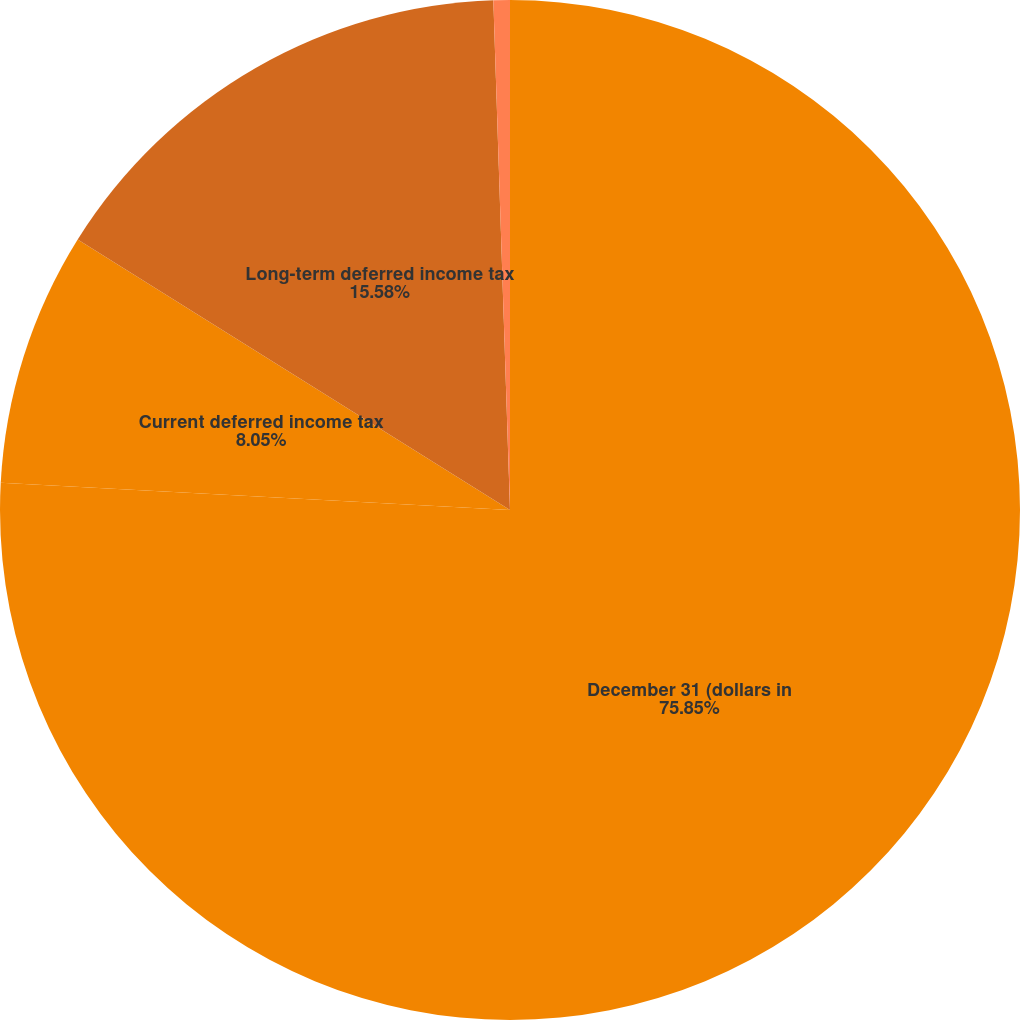Convert chart to OTSL. <chart><loc_0><loc_0><loc_500><loc_500><pie_chart><fcel>December 31 (dollars in<fcel>Current deferred income tax<fcel>Long-term deferred income tax<fcel>Net asset (liability)<nl><fcel>75.85%<fcel>8.05%<fcel>15.58%<fcel>0.52%<nl></chart> 